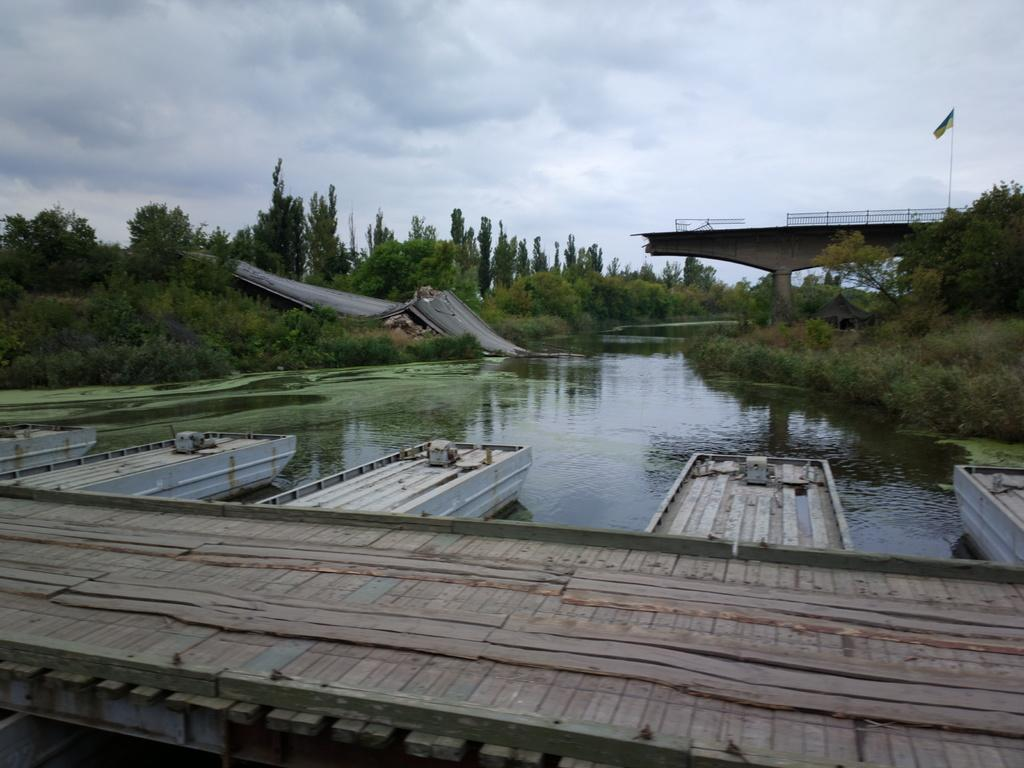How many bridges can be seen in the image? There are two bridges in the image. What type of vegetation is present in the image? There are trees in the image. What is the body of water in the image? There is water visible in the image. What type of barrier is present in the image? There is a fence in the image. What symbol can be seen in the image? There is a flag in the image. What is visible in the background of the image? The sky with clouds is visible in the background of the image. What type of wall is present in the image? There is no wall present in the image. What list can be seen in the image? There is no list present in the image. What nation is represented by the flag in the image? The image does not provide enough information to determine the nation represented by the flag. 